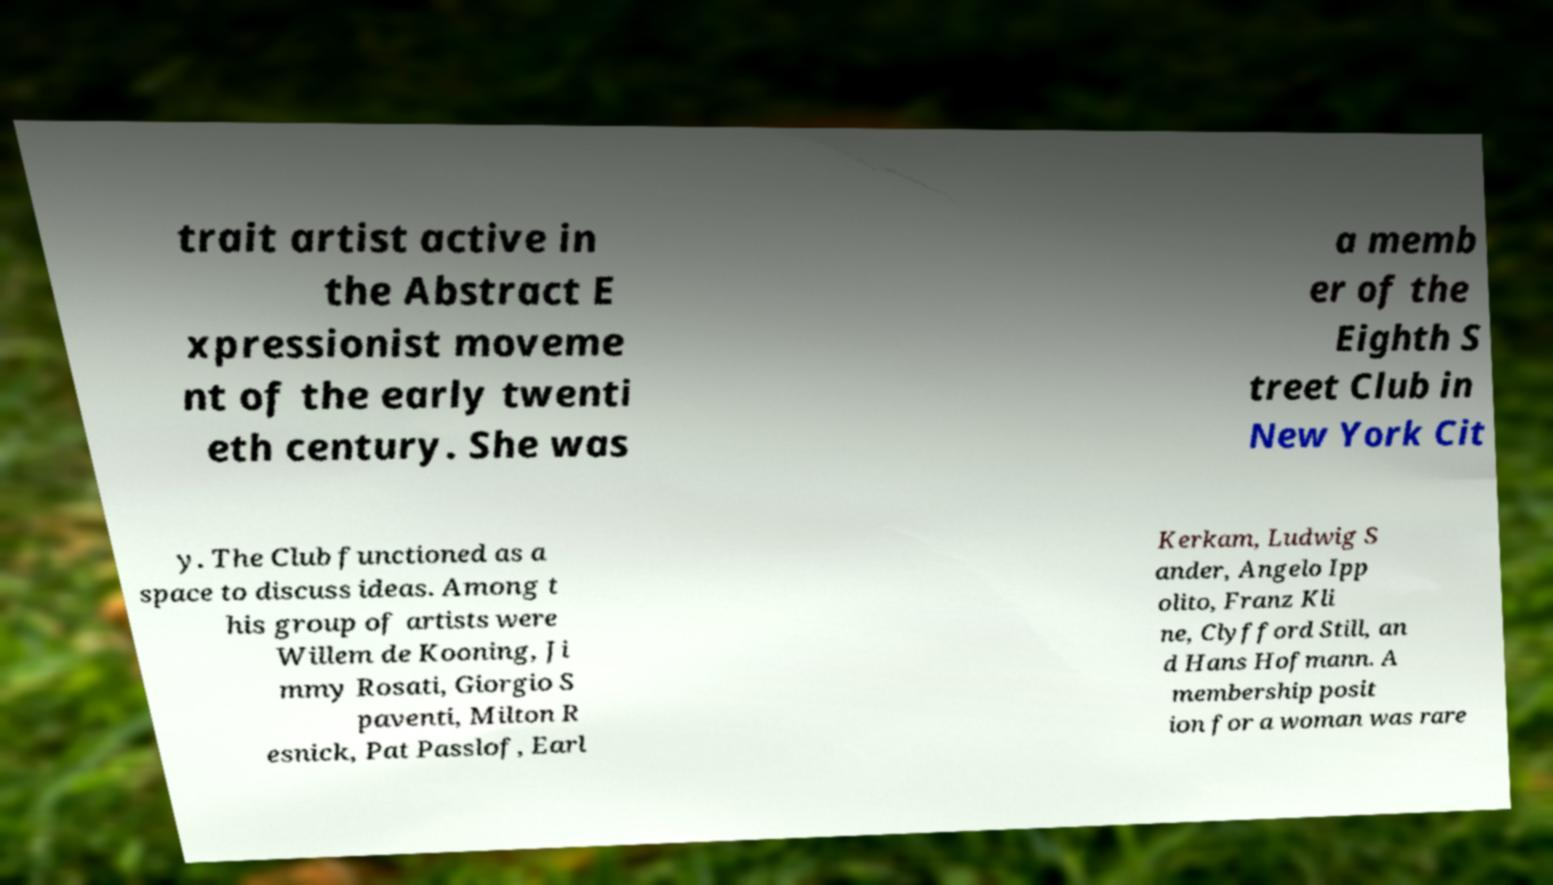There's text embedded in this image that I need extracted. Can you transcribe it verbatim? trait artist active in the Abstract E xpressionist moveme nt of the early twenti eth century. She was a memb er of the Eighth S treet Club in New York Cit y. The Club functioned as a space to discuss ideas. Among t his group of artists were Willem de Kooning, Ji mmy Rosati, Giorgio S paventi, Milton R esnick, Pat Passlof, Earl Kerkam, Ludwig S ander, Angelo Ipp olito, Franz Kli ne, Clyfford Still, an d Hans Hofmann. A membership posit ion for a woman was rare 